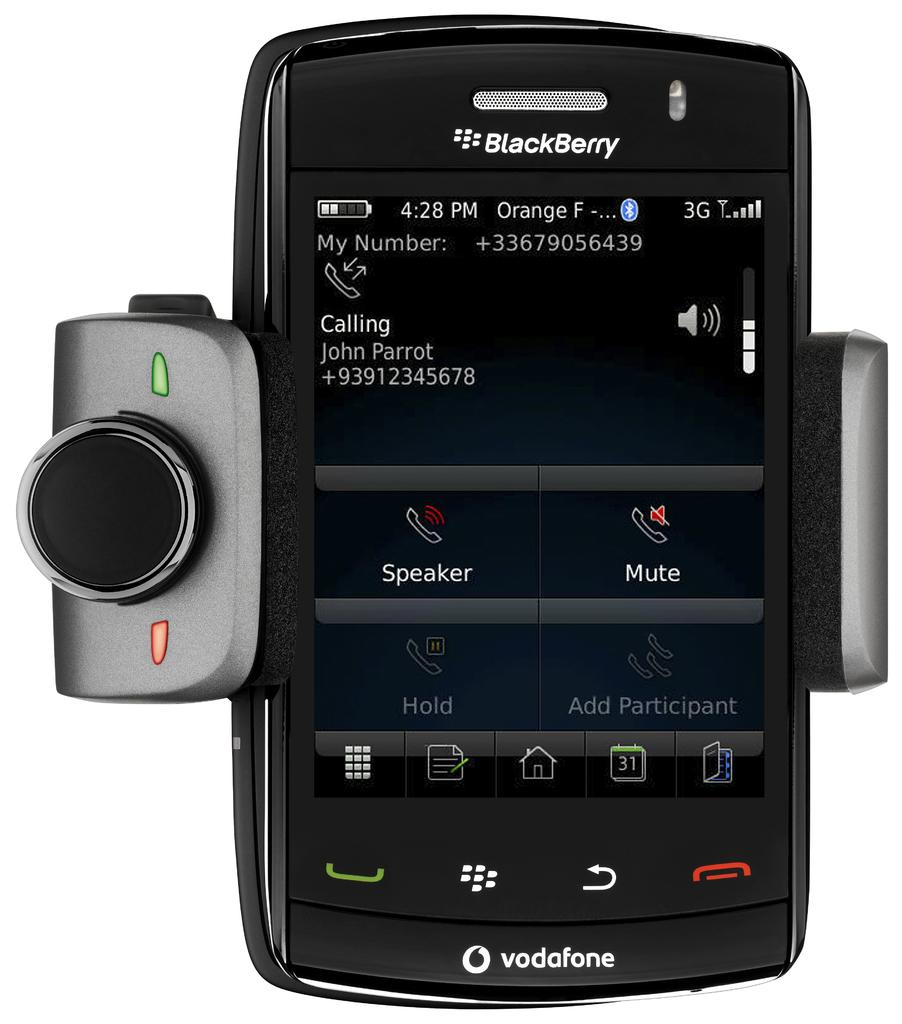Provide a one-sentence caption for the provided image. A Blackberry screen shows Johnny Parrot's phone number. 